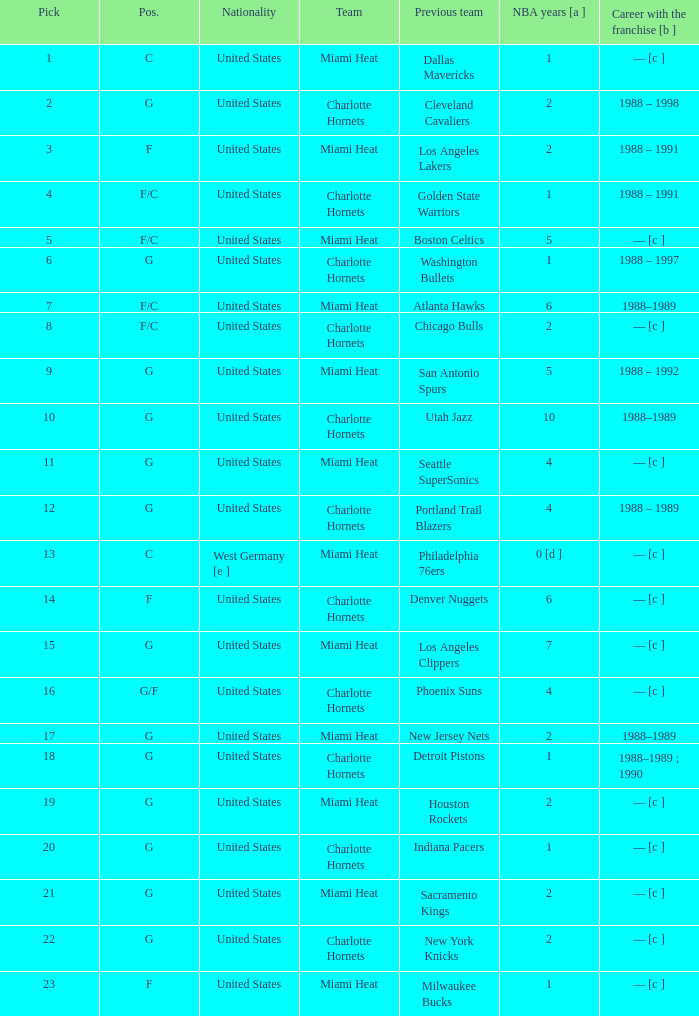What was the former team of the player who has 4 nba seasons under their belt and was drafted below the 16th pick? Seattle SuperSonics, Portland Trail Blazers. 